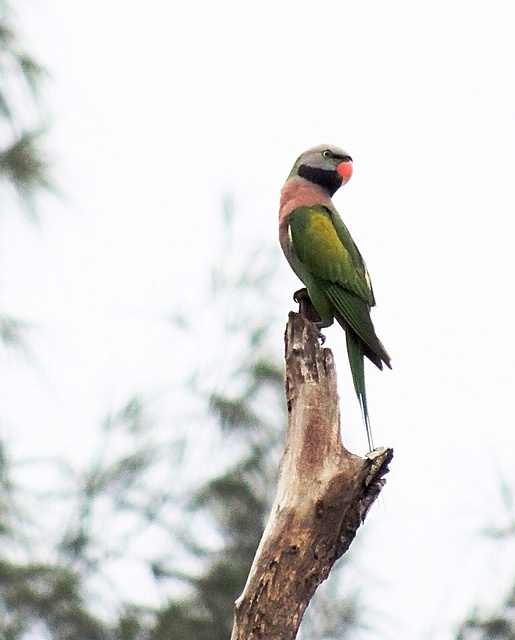Describe the objects in this image and their specific colors. I can see a bird in lightgray, black, darkgreen, and gray tones in this image. 